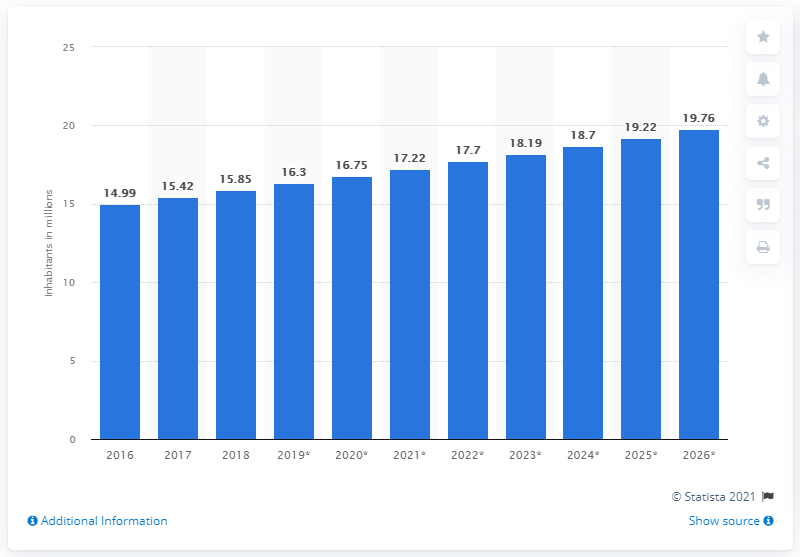Give some essential details in this illustration. In 2018, the population of Senegal was approximately 15.85 million people. 